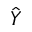<formula> <loc_0><loc_0><loc_500><loc_500>\hat { Y }</formula> 